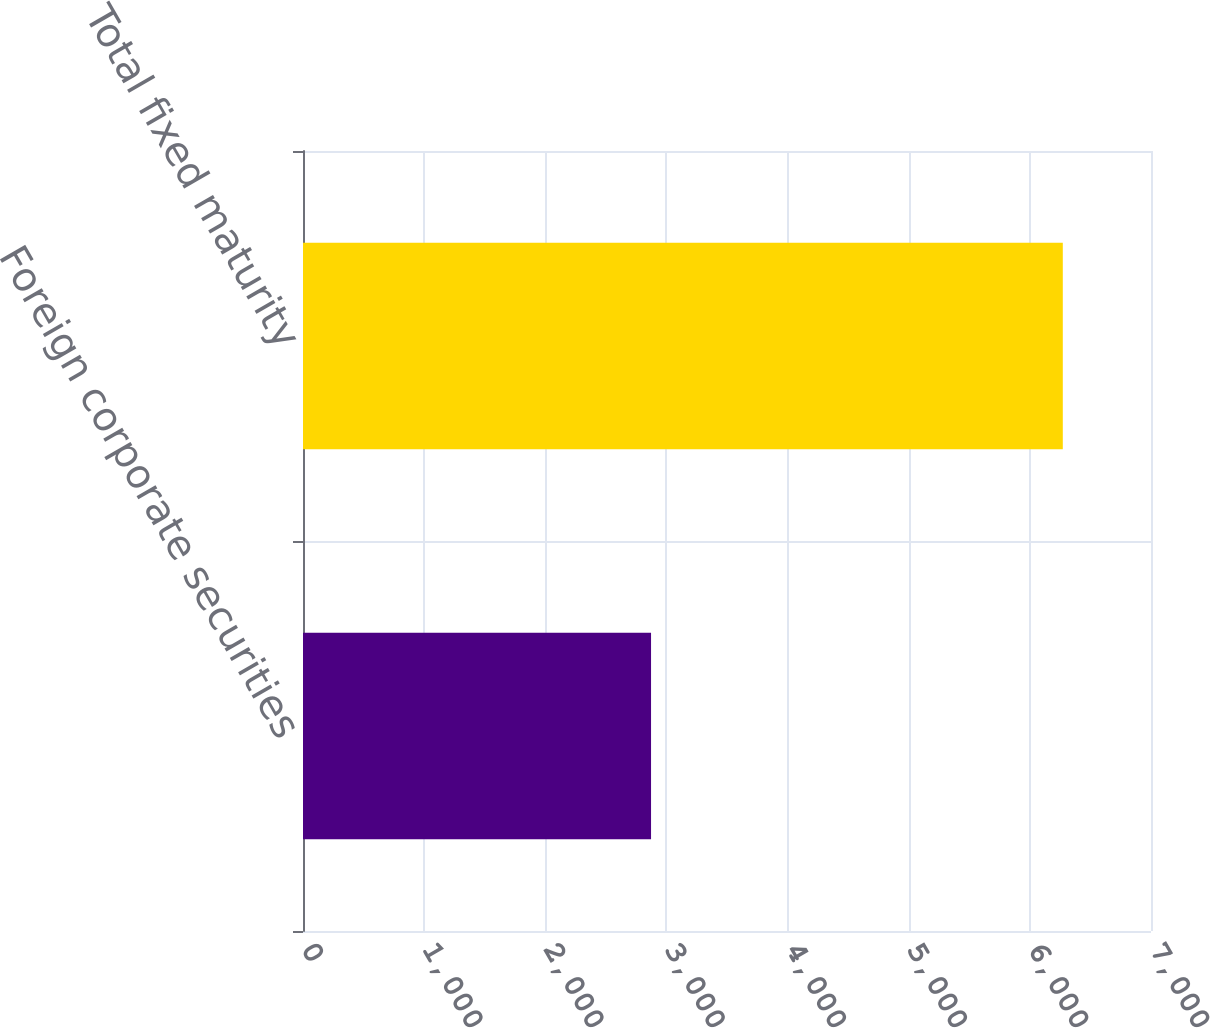<chart> <loc_0><loc_0><loc_500><loc_500><bar_chart><fcel>Foreign corporate securities<fcel>Total fixed maturity<nl><fcel>2873<fcel>6272<nl></chart> 